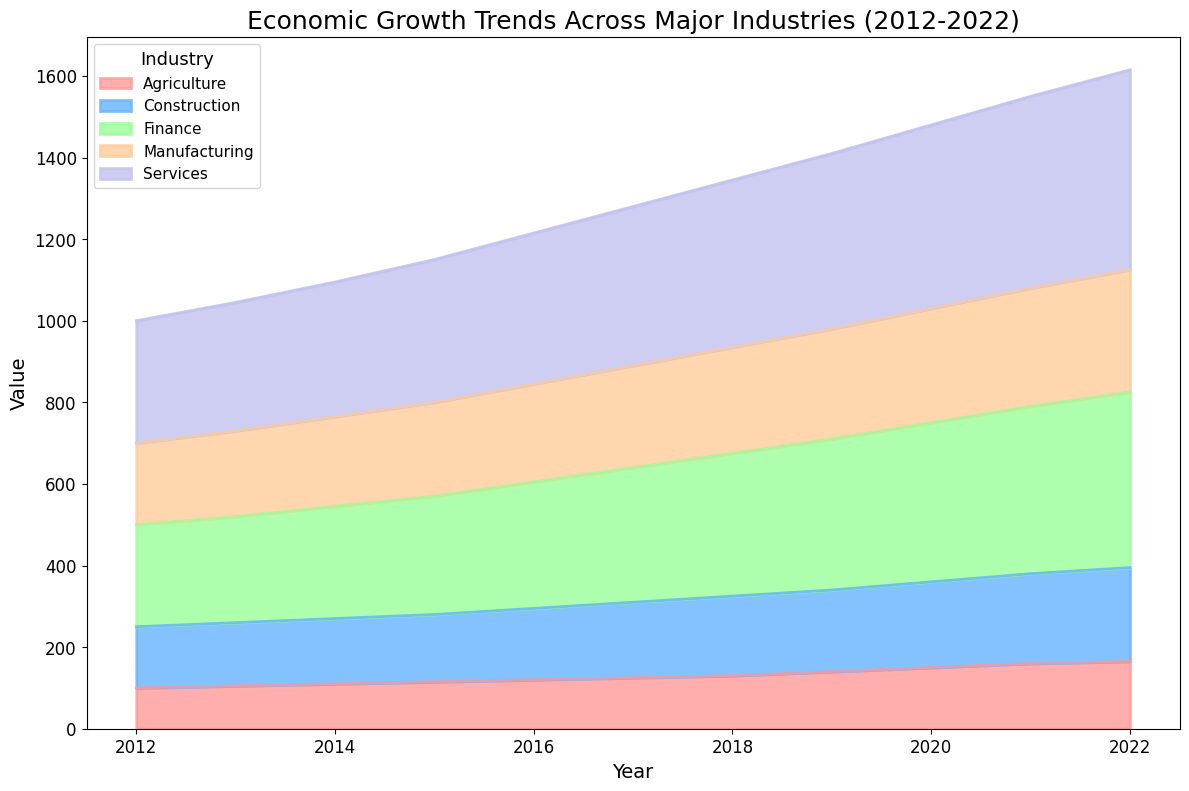What is the overall trend of the Services industry over the past decade? The Services industry has shown a consistent upward trend from 2012 to 2022. Values increased yearly from 300 in 2012 to 490 in 2022.
Answer: Upward Between Agriculture and Manufacturing, which industry had a higher value in 2020? In 2020, the value of Agriculture was 150, whereas the value of Manufacturing was 280. Therefore, Manufacturing had a higher value in 2020.
Answer: Manufacturing Which industry had the smallest growth rate from 2012 to 2022? The smallest growth can be observed by measuring the difference between the final and initial values for each industry. Agriculture grew from 100 to 165 (65 growth), Manufacturing from 200 to 300 (100 growth), Services from 300 to 490 (190 growth), Construction from 150 to 230 (80 growth), and Finance from 250 to 430 (180 growth). Therefore, Agriculture had the smallest growth rate.
Answer: Agriculture What was the value of the Finance industry in 2015 compared to the Construction industry? In 2015, the value of the Finance industry was 290, while the value of the Construction industry was 165. Hence, Finance had a higher value compared to Construction.
Answer: Finance By how much did the value of Agriculture increase from 2019 to 2022? The value of Agriculture was 140 in 2019 and increased to 165 in 2022. The difference is 165 - 140 = 25.
Answer: 25 Which industry showed a relatively constant value increase each year? By observing the plot, the Manufacturing industry appears to have a nearly linear increase. Each year, its value increases by approximately 10 units smoothly.
Answer: Manufacturing Does the visual representation show any overlapping areas between industries? Yes, the usage of a stacked area chart results in overlapping areas between industries, especially with high-growth industries like Services and Finance covering the underlying industries.
Answer: Yes What was the value of the Construction industry in 2017 compared to its value in 2022? The value of the Construction industry in 2017 was 185 and in 2022 was 230.
Answer: 185, 230 Between Finance and Services, which industry had a higher value in 2016? In 2016, the value of Finance was 310, whereas the value of Services was 370. Therefore, Services had a higher value.
Answer: Services 